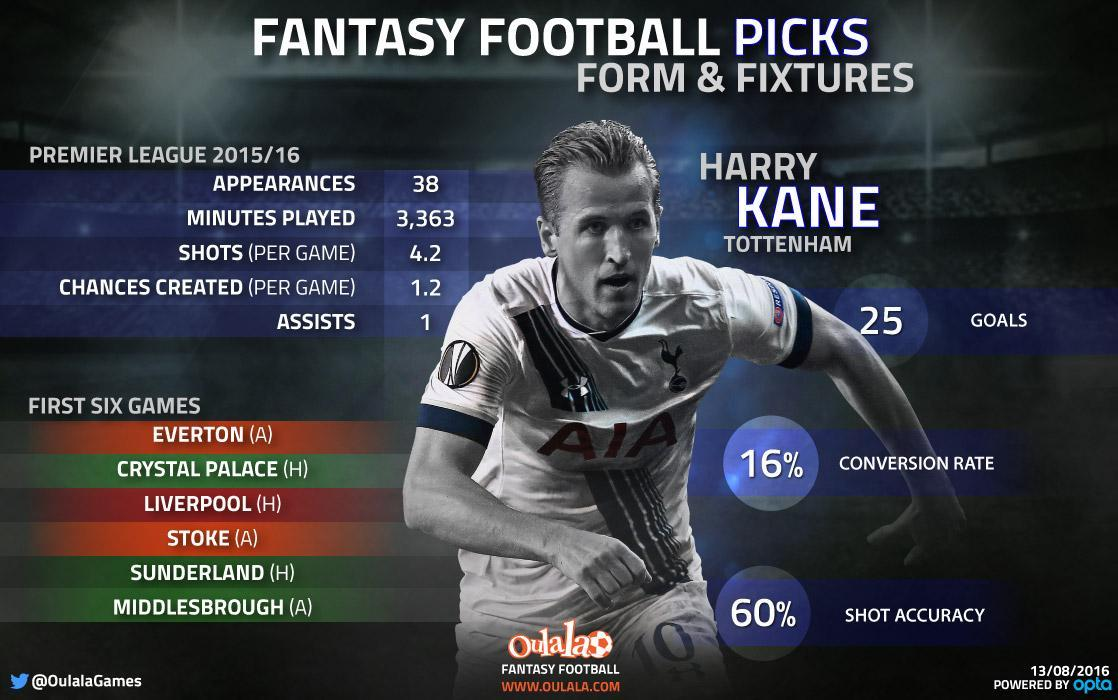What is written on the jersey t-shirt of the player?
Answer the question with a short phrase. AIA What is the color of the jersey of the player - white, black or blue? white What is the middle name of the player? kane What is the name of the player in this image? harry kane tottenham Which number is written on the shorts of the player? 10 